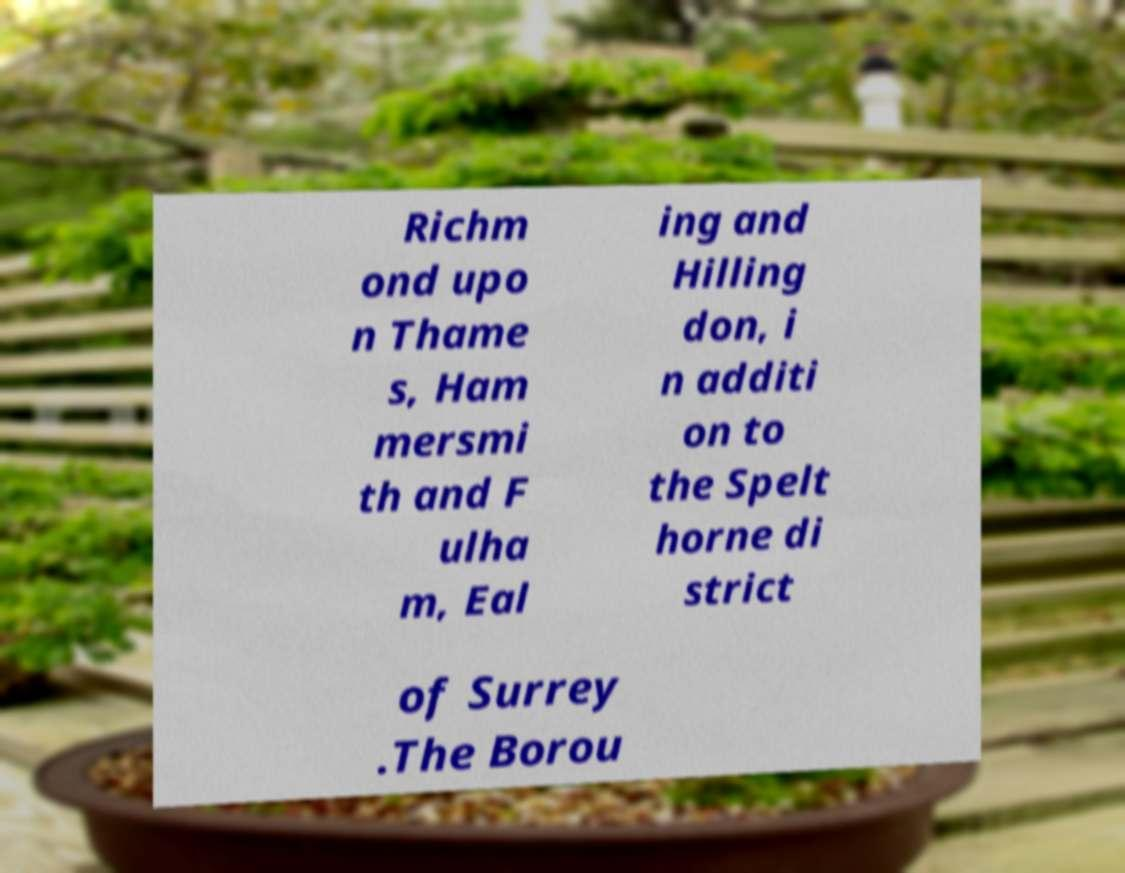There's text embedded in this image that I need extracted. Can you transcribe it verbatim? Richm ond upo n Thame s, Ham mersmi th and F ulha m, Eal ing and Hilling don, i n additi on to the Spelt horne di strict of Surrey .The Borou 